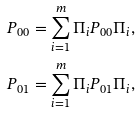Convert formula to latex. <formula><loc_0><loc_0><loc_500><loc_500>P _ { 0 0 } & = \sum _ { i = 1 } ^ { m } \Pi _ { i } P _ { 0 0 } \Pi _ { i } , \\ P _ { 0 1 } & = \sum _ { i = 1 } ^ { m } \Pi _ { i } P _ { 0 1 } \Pi _ { i } ,</formula> 